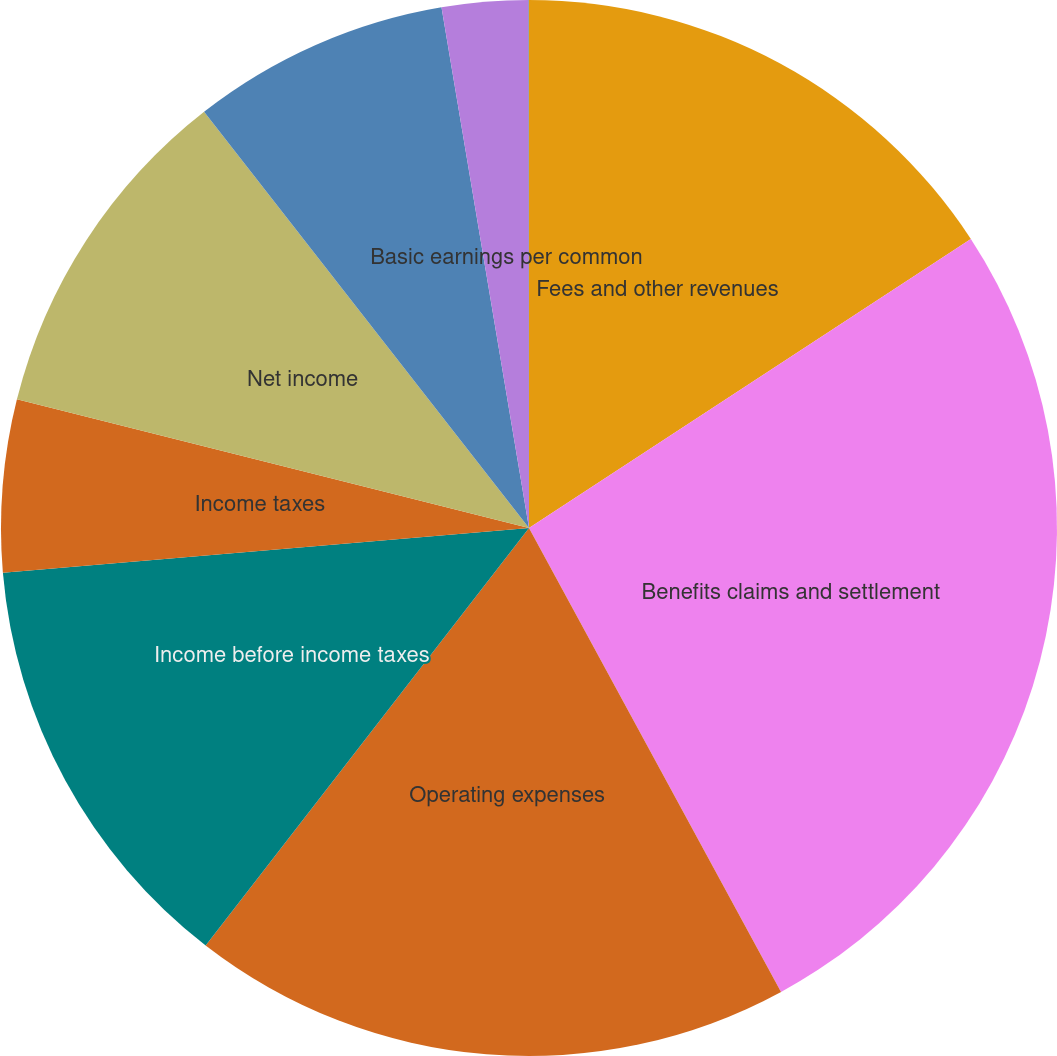Convert chart to OTSL. <chart><loc_0><loc_0><loc_500><loc_500><pie_chart><fcel>Fees and other revenues<fcel>Benefits claims and settlement<fcel>Operating expenses<fcel>Income before income taxes<fcel>Income taxes<fcel>Net income<fcel>Net income available to common<fcel>Basic earnings per common<fcel>Diluted earnings per common<nl><fcel>15.78%<fcel>26.3%<fcel>18.41%<fcel>13.16%<fcel>5.27%<fcel>10.53%<fcel>7.9%<fcel>2.64%<fcel>0.01%<nl></chart> 